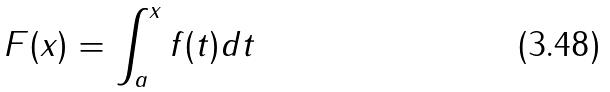<formula> <loc_0><loc_0><loc_500><loc_500>F ( x ) = \int _ { a } ^ { x } f ( t ) d t</formula> 